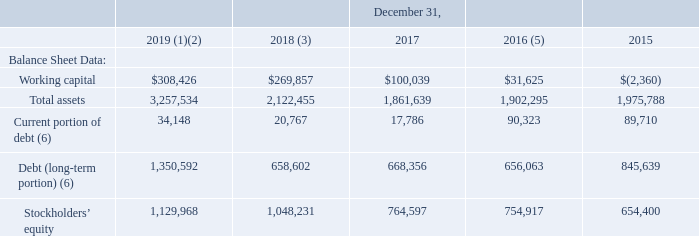ITEM 6. SELECTED FINANCIAL DATA
The following selected financial data has been derived from our consolidated financial statements (in thousands, except per share data). This data should be read together with Item 7, “Management’s Discussion and Analysis of Financial Condition and Results of Operations”, and the consolidated financial statements and related notes included elsewhere in this annual report. The financial information below is not necessarily indicative of the results of future operations. Future results could differ materially from historical results due to many factors, including those discussed in Item 1A, Risk Factors.
(1) The consolidated balance sheet and statement of operations for the year ended December 31, 2019, includes the acquisition of Speedpay as discussed in Note 3, Acquisition, to our Notes to Consolidated Financial Statements in Part IV, Item 15 of this Form 10-K.
(2) The consolidated balance sheet and statement of operations for the year ended December 31, 2019, reflects the application of Accounting Standards Update (“ASU”) 2016-02, Leases (codified as “ASC 842”) as discussed in Note 14, Leases, to our Notes to Consolidated Financial Statements.
(3) The consolidated balance sheet and statement of operations for the year ended December 31, 2018, reflects the adoption of ASU 2014-09, Revenue from Contracts with Customers (codified as “ASC 606”), as discussed in Note 2, Revenue, to our Notes to Consolidated Financial Statements, including a cumulative adjustment of $244.0 million to retained earnings.
(4) The consolidated statement of operations for the year ended December 31, 2017, reflects the Baldwin Hackett & Meeks, Inc. (“BHMI”) judgment. We recorded $46.7 million in general and administrative expense and $1.4 million in interest expense, as discussed in Note 15, Commitments and Contingencies, to our Notes to Consolidated Financial Statements.
(5) The consolidated balance sheet and statement of operations for the year ended December 31, 2016, reflects the sale of Community Financial Services assets and liabilities.
(6) During the year ended December 31, 2019, we borrowed $500.0 million in the form of a new senior secured term loan and drew $250.0 million on the available Revolving Credit Facility to fund the acquisition of Speedpay. During the year ended December 31, 2018, we issued $400.0 million in senior notes due August 15, 2026. We used the net proceeds of these senior notes to redeem our outstanding $300.0 million senior notes due 2020, which we originally entered in to during the year ended December 31, 2013. See Note 5, Debt, to our Notes to Consolidated Financial Statements for additional information.
What was the working capital in 2018?
Answer scale should be: thousand. $269,857. What was the working capital in 2019?
Answer scale should be: thousand. $308,426. What was the total assets in 2015?
Answer scale should be: thousand. 1,975,788. What was the change in working capital between 2018 and 2019?
Answer scale should be: thousand. $308,426-$269,857
Answer: 38569. What was the change in current portion of debt between 2016 and 2017?
Answer scale should be: thousand. 90,323-17,786
Answer: 72537. What was the change in total assets between 2018 and 2019?
Answer scale should be: percent. (3,257,534-2,122,455)/2,122,455
Answer: 53.48. 